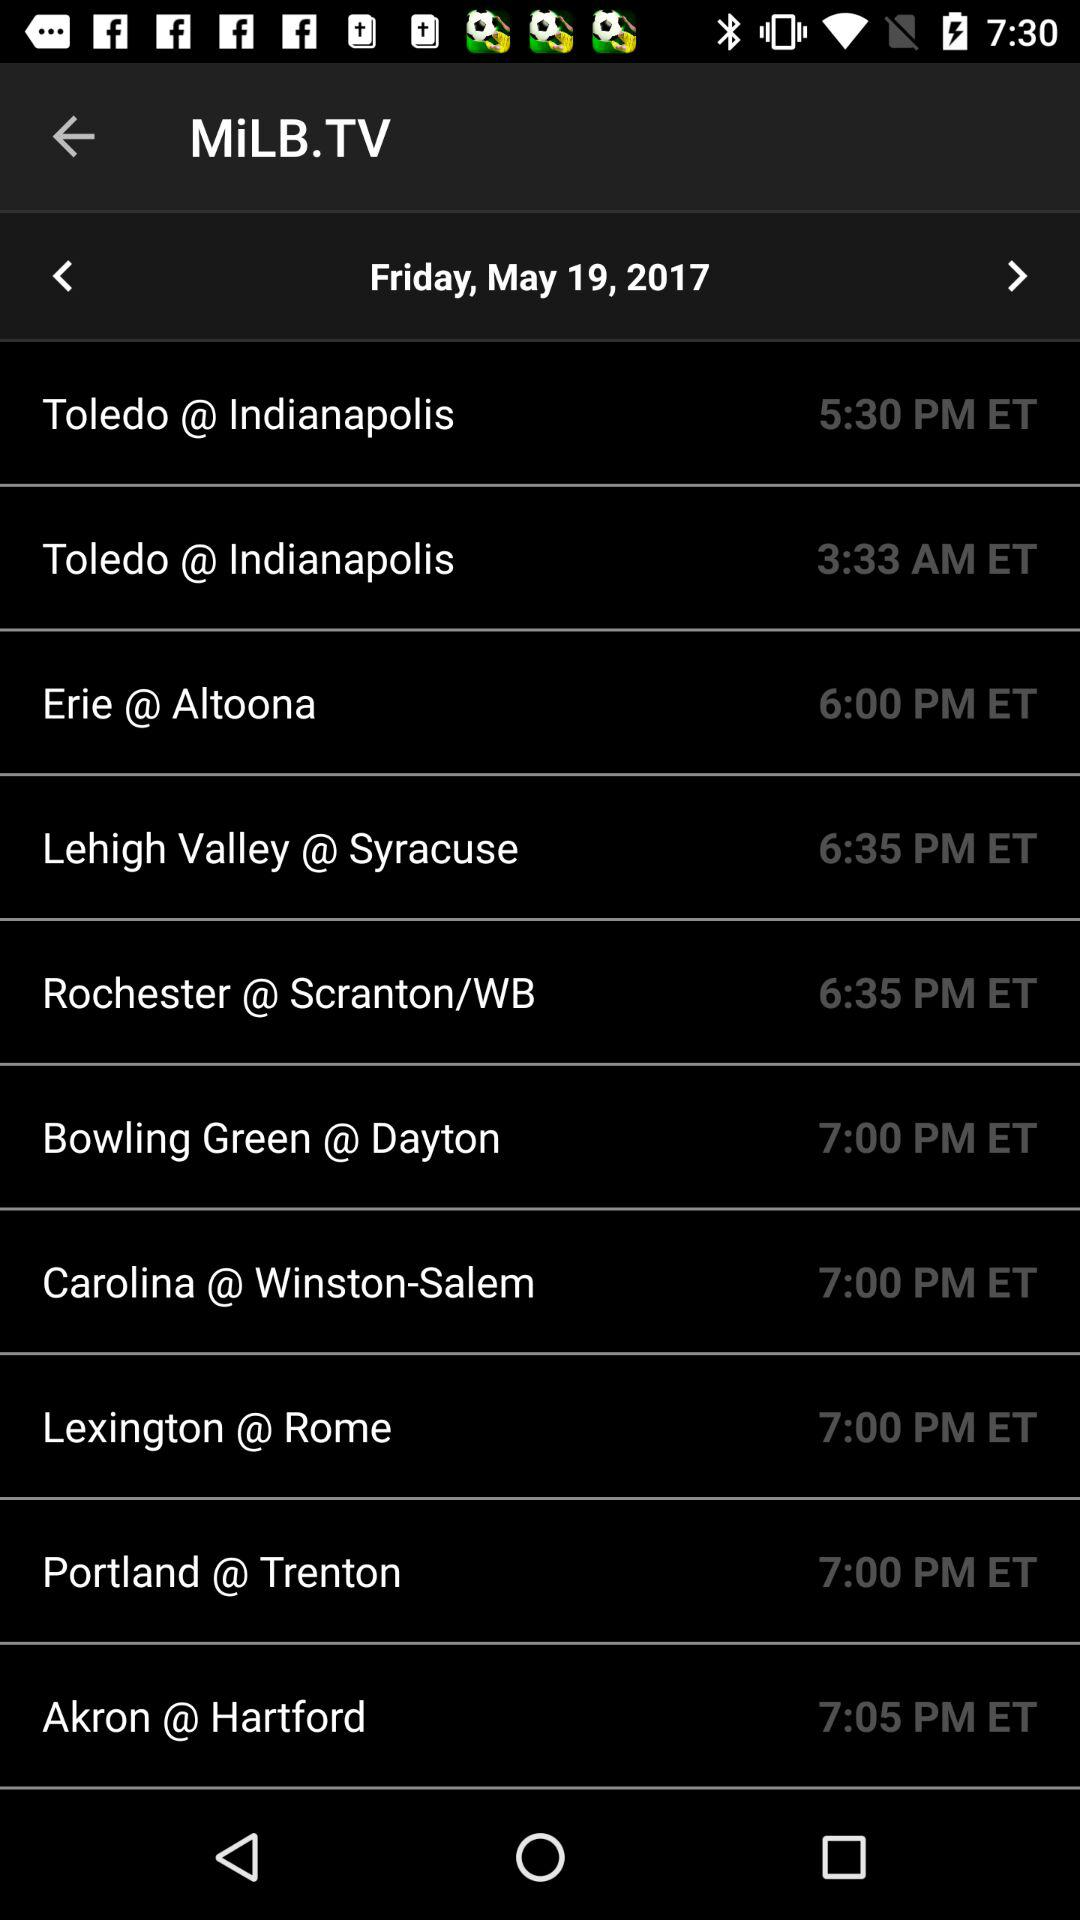What is the date? The date is Friday, May 19, 2017. 